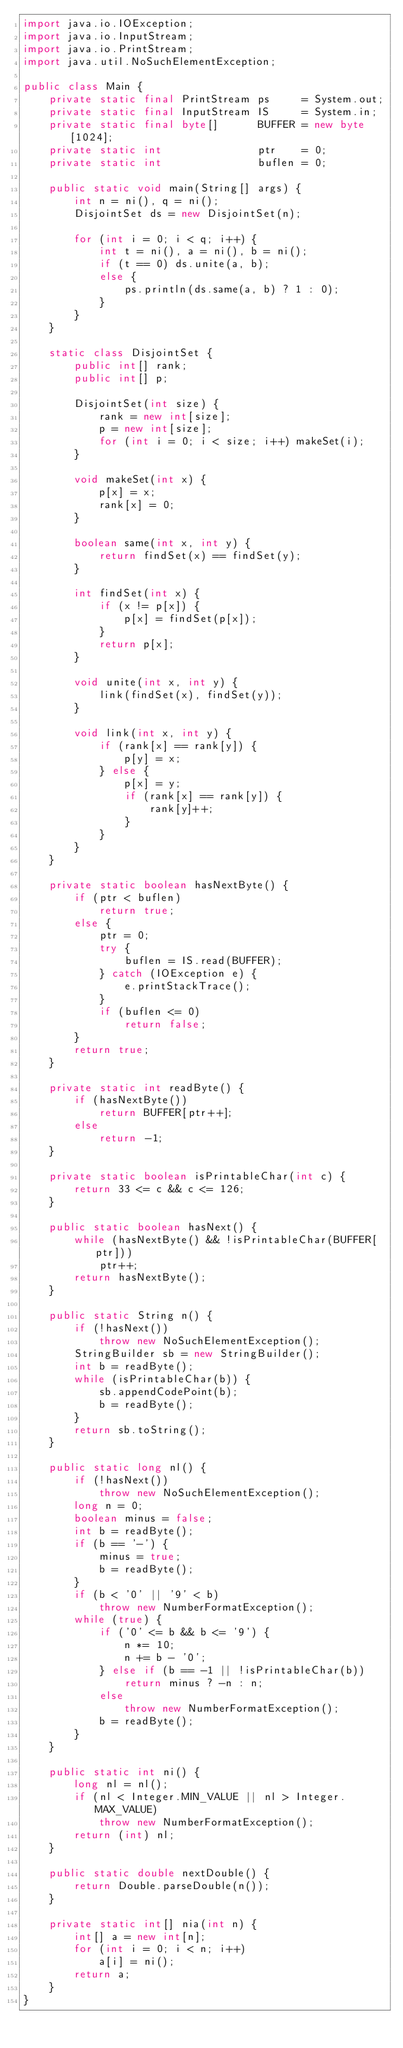<code> <loc_0><loc_0><loc_500><loc_500><_Java_>import java.io.IOException;
import java.io.InputStream;
import java.io.PrintStream;
import java.util.NoSuchElementException;

public class Main {
    private static final PrintStream ps     = System.out;
    private static final InputStream IS     = System.in;
    private static final byte[]      BUFFER = new byte[1024];
    private static int               ptr    = 0;
    private static int               buflen = 0;
    
    public static void main(String[] args) {
        int n = ni(), q = ni();
        DisjointSet ds = new DisjointSet(n);
        
        for (int i = 0; i < q; i++) {
            int t = ni(), a = ni(), b = ni();
            if (t == 0) ds.unite(a, b);
            else {
                ps.println(ds.same(a, b) ? 1 : 0);
            }
        }
    }
    
    static class DisjointSet {
        public int[] rank;
        public int[] p;
        
        DisjointSet(int size) {
            rank = new int[size];
            p = new int[size];
            for (int i = 0; i < size; i++) makeSet(i);
        }
        
        void makeSet(int x) {
            p[x] = x;
            rank[x] = 0;
        }
        
        boolean same(int x, int y) {
            return findSet(x) == findSet(y);
        }
        
        int findSet(int x) {
            if (x != p[x]) {
                p[x] = findSet(p[x]);
            }
            return p[x];
        }
        
        void unite(int x, int y) {
            link(findSet(x), findSet(y));
        }
        
        void link(int x, int y) {
            if (rank[x] == rank[y]) {
                p[y] = x;
            } else {
                p[x] = y;
                if (rank[x] == rank[y]) {
                    rank[y]++;
                }
            }
        }
    }

    private static boolean hasNextByte() {
        if (ptr < buflen)
            return true;
        else {
            ptr = 0;
            try {
                buflen = IS.read(BUFFER);
            } catch (IOException e) {
                e.printStackTrace();
            }
            if (buflen <= 0)
                return false;
        }
        return true;
    }

    private static int readByte() {
        if (hasNextByte())
            return BUFFER[ptr++];
        else
            return -1;
    }

    private static boolean isPrintableChar(int c) {
        return 33 <= c && c <= 126;
    }

    public static boolean hasNext() {
        while (hasNextByte() && !isPrintableChar(BUFFER[ptr]))
            ptr++;
        return hasNextByte();
    }

    public static String n() {
        if (!hasNext())
            throw new NoSuchElementException();
        StringBuilder sb = new StringBuilder();
        int b = readByte();
        while (isPrintableChar(b)) {
            sb.appendCodePoint(b);
            b = readByte();
        }
        return sb.toString();
    }

    public static long nl() {
        if (!hasNext())
            throw new NoSuchElementException();
        long n = 0;
        boolean minus = false;
        int b = readByte();
        if (b == '-') {
            minus = true;
            b = readByte();
        }
        if (b < '0' || '9' < b)
            throw new NumberFormatException();
        while (true) {
            if ('0' <= b && b <= '9') {
                n *= 10;
                n += b - '0';
            } else if (b == -1 || !isPrintableChar(b))
                return minus ? -n : n;
            else
                throw new NumberFormatException();
            b = readByte();
        }
    }

    public static int ni() {
        long nl = nl();
        if (nl < Integer.MIN_VALUE || nl > Integer.MAX_VALUE)
            throw new NumberFormatException();
        return (int) nl;
    }

    public static double nextDouble() {
        return Double.parseDouble(n());
    }

    private static int[] nia(int n) {
        int[] a = new int[n];
        for (int i = 0; i < n; i++)
            a[i] = ni();
        return a;
    }
}
</code> 